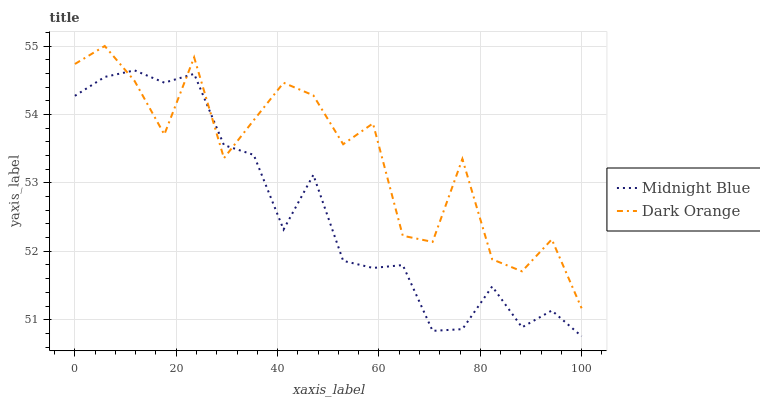Does Midnight Blue have the maximum area under the curve?
Answer yes or no. No. Is Midnight Blue the roughest?
Answer yes or no. No. Does Midnight Blue have the highest value?
Answer yes or no. No. 